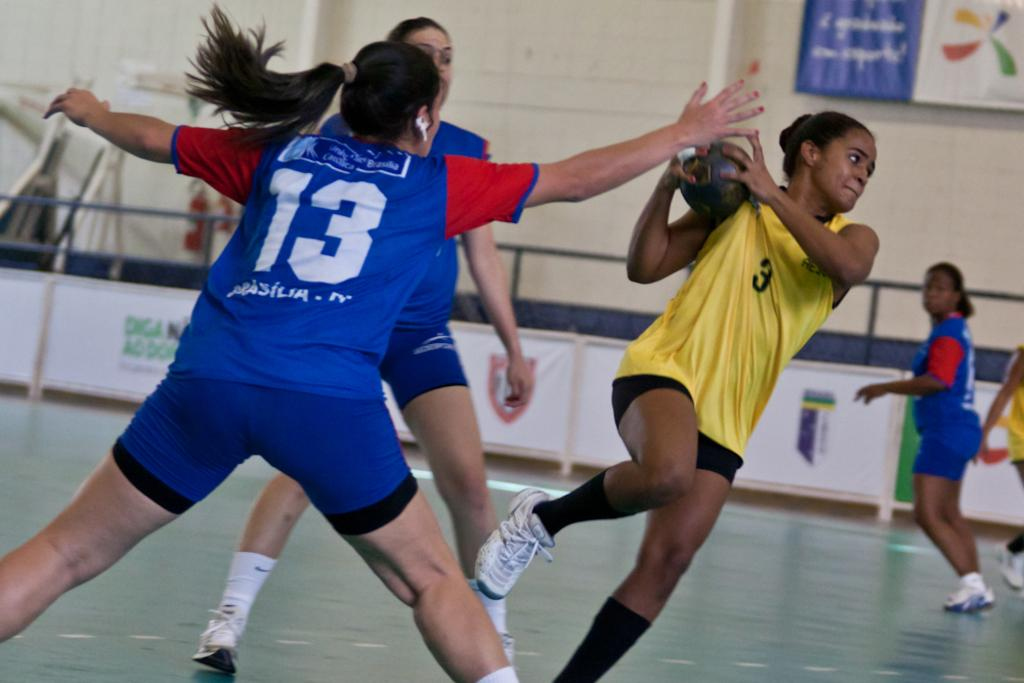How many women are in the image? There are women in the image, but the exact number is not specified. What is one of the women holding? One woman is holding a ball. What can be seen in the background of the image? There is a wall and a fence in the background of the image. What is attached to the wall in the background? There is a banner attached to the wall in the background of the image. What type of muscle is being exercised by the women in the image? There is no indication in the image that the women are exercising any muscles, so it cannot be determined from the picture. 